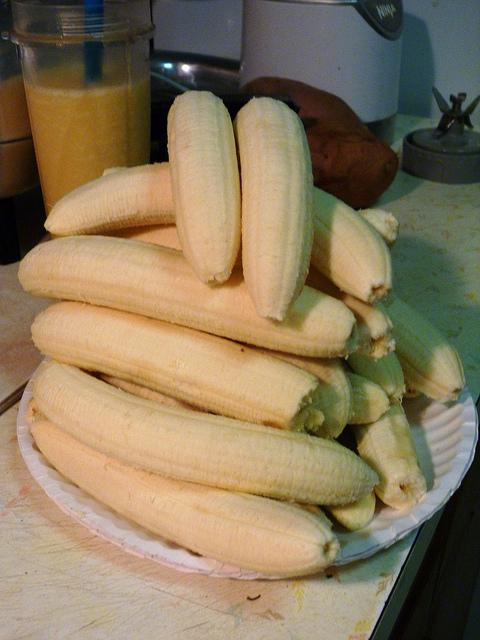What happened to these bananas? peeled 